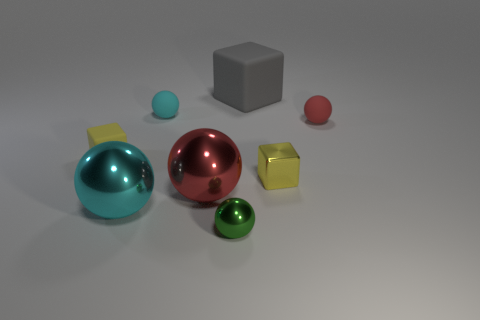There is a matte cube right of the cyan rubber ball; are there any small green objects that are to the right of it?
Keep it short and to the point. No. Does the big rubber block have the same color as the tiny rubber cube?
Keep it short and to the point. No. How many other objects are the same shape as the green object?
Offer a terse response. 4. Is the number of small cyan matte things that are behind the tiny cyan matte object greater than the number of metal objects that are to the left of the large gray cube?
Ensure brevity in your answer.  No. There is a matte thing that is to the left of the tiny cyan matte sphere; is it the same size as the rubber ball on the right side of the tiny cyan sphere?
Your response must be concise. Yes. There is a gray object; what shape is it?
Your response must be concise. Cube. What size is the rubber thing that is the same color as the shiny block?
Give a very brief answer. Small. There is a cube that is made of the same material as the big red ball; what color is it?
Offer a very short reply. Yellow. Is the gray block made of the same material as the tiny yellow thing to the right of the big gray thing?
Provide a short and direct response. No. What color is the big block?
Your answer should be very brief. Gray. 